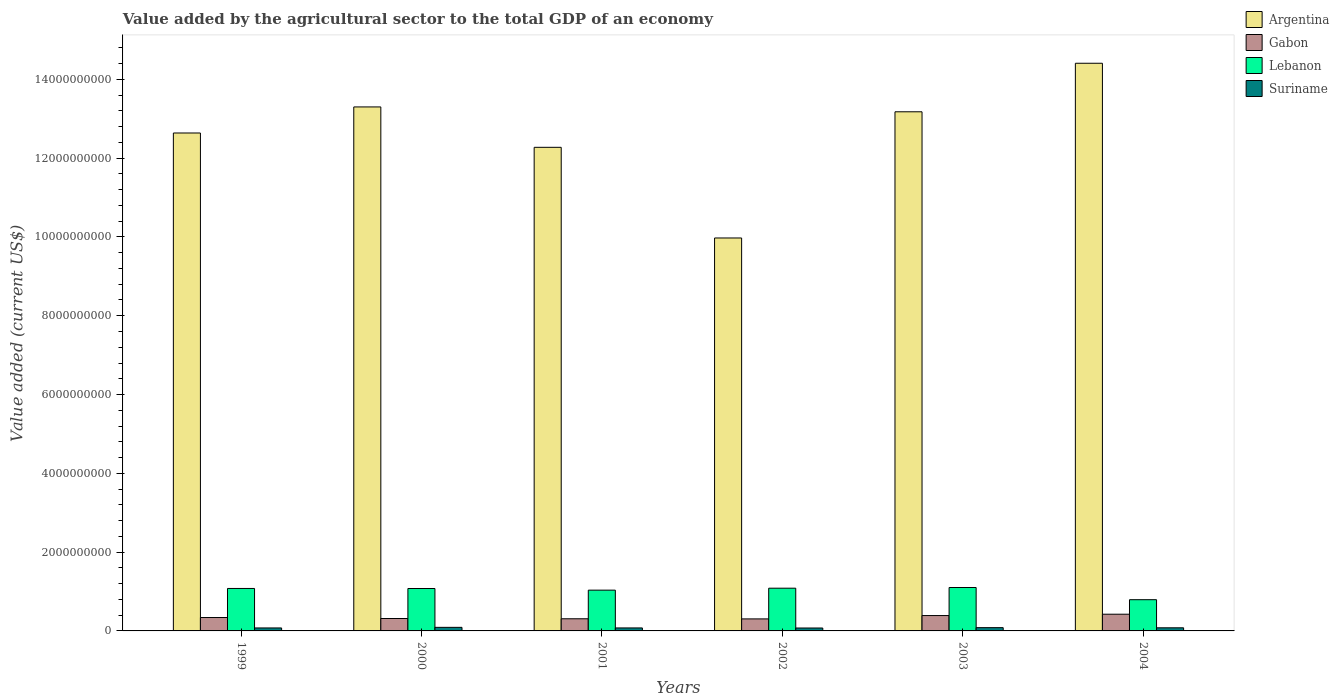How many different coloured bars are there?
Keep it short and to the point. 4. How many groups of bars are there?
Your answer should be very brief. 6. Are the number of bars on each tick of the X-axis equal?
Provide a succinct answer. Yes. What is the label of the 3rd group of bars from the left?
Keep it short and to the point. 2001. In how many cases, is the number of bars for a given year not equal to the number of legend labels?
Provide a succinct answer. 0. What is the value added by the agricultural sector to the total GDP in Argentina in 1999?
Offer a very short reply. 1.26e+1. Across all years, what is the maximum value added by the agricultural sector to the total GDP in Gabon?
Make the answer very short. 4.24e+08. Across all years, what is the minimum value added by the agricultural sector to the total GDP in Argentina?
Your response must be concise. 9.97e+09. In which year was the value added by the agricultural sector to the total GDP in Suriname maximum?
Your response must be concise. 2000. What is the total value added by the agricultural sector to the total GDP in Suriname in the graph?
Make the answer very short. 4.78e+08. What is the difference between the value added by the agricultural sector to the total GDP in Lebanon in 2002 and that in 2004?
Provide a succinct answer. 2.92e+08. What is the difference between the value added by the agricultural sector to the total GDP in Argentina in 2003 and the value added by the agricultural sector to the total GDP in Suriname in 2004?
Your response must be concise. 1.31e+1. What is the average value added by the agricultural sector to the total GDP in Suriname per year?
Your answer should be very brief. 7.97e+07. In the year 2002, what is the difference between the value added by the agricultural sector to the total GDP in Gabon and value added by the agricultural sector to the total GDP in Lebanon?
Provide a short and direct response. -7.80e+08. What is the ratio of the value added by the agricultural sector to the total GDP in Lebanon in 1999 to that in 2001?
Ensure brevity in your answer.  1.04. What is the difference between the highest and the second highest value added by the agricultural sector to the total GDP in Gabon?
Your answer should be compact. 3.40e+07. What is the difference between the highest and the lowest value added by the agricultural sector to the total GDP in Lebanon?
Provide a succinct answer. 3.09e+08. Is the sum of the value added by the agricultural sector to the total GDP in Lebanon in 2001 and 2002 greater than the maximum value added by the agricultural sector to the total GDP in Argentina across all years?
Provide a succinct answer. No. Is it the case that in every year, the sum of the value added by the agricultural sector to the total GDP in Argentina and value added by the agricultural sector to the total GDP in Lebanon is greater than the sum of value added by the agricultural sector to the total GDP in Suriname and value added by the agricultural sector to the total GDP in Gabon?
Offer a very short reply. Yes. What does the 2nd bar from the left in 2004 represents?
Give a very brief answer. Gabon. What does the 4th bar from the right in 2000 represents?
Provide a short and direct response. Argentina. Are all the bars in the graph horizontal?
Make the answer very short. No. Does the graph contain grids?
Keep it short and to the point. No. Where does the legend appear in the graph?
Offer a terse response. Top right. What is the title of the graph?
Ensure brevity in your answer.  Value added by the agricultural sector to the total GDP of an economy. Does "Cabo Verde" appear as one of the legend labels in the graph?
Ensure brevity in your answer.  No. What is the label or title of the Y-axis?
Offer a terse response. Value added (current US$). What is the Value added (current US$) in Argentina in 1999?
Keep it short and to the point. 1.26e+1. What is the Value added (current US$) of Gabon in 1999?
Your answer should be compact. 3.40e+08. What is the Value added (current US$) in Lebanon in 1999?
Your answer should be very brief. 1.08e+09. What is the Value added (current US$) in Suriname in 1999?
Ensure brevity in your answer.  7.56e+07. What is the Value added (current US$) in Argentina in 2000?
Offer a terse response. 1.33e+1. What is the Value added (current US$) of Gabon in 2000?
Keep it short and to the point. 3.15e+08. What is the Value added (current US$) of Lebanon in 2000?
Keep it short and to the point. 1.08e+09. What is the Value added (current US$) of Suriname in 2000?
Your answer should be compact. 9.07e+07. What is the Value added (current US$) of Argentina in 2001?
Ensure brevity in your answer.  1.23e+1. What is the Value added (current US$) in Gabon in 2001?
Make the answer very short. 3.08e+08. What is the Value added (current US$) in Lebanon in 2001?
Make the answer very short. 1.03e+09. What is the Value added (current US$) in Suriname in 2001?
Make the answer very short. 7.59e+07. What is the Value added (current US$) in Argentina in 2002?
Make the answer very short. 9.97e+09. What is the Value added (current US$) in Gabon in 2002?
Provide a succinct answer. 3.05e+08. What is the Value added (current US$) of Lebanon in 2002?
Provide a succinct answer. 1.08e+09. What is the Value added (current US$) of Suriname in 2002?
Ensure brevity in your answer.  7.38e+07. What is the Value added (current US$) of Argentina in 2003?
Keep it short and to the point. 1.32e+1. What is the Value added (current US$) in Gabon in 2003?
Ensure brevity in your answer.  3.90e+08. What is the Value added (current US$) of Lebanon in 2003?
Make the answer very short. 1.10e+09. What is the Value added (current US$) of Suriname in 2003?
Ensure brevity in your answer.  8.31e+07. What is the Value added (current US$) in Argentina in 2004?
Your answer should be very brief. 1.44e+1. What is the Value added (current US$) of Gabon in 2004?
Your answer should be very brief. 4.24e+08. What is the Value added (current US$) in Lebanon in 2004?
Your response must be concise. 7.93e+08. What is the Value added (current US$) in Suriname in 2004?
Keep it short and to the point. 7.91e+07. Across all years, what is the maximum Value added (current US$) in Argentina?
Make the answer very short. 1.44e+1. Across all years, what is the maximum Value added (current US$) of Gabon?
Give a very brief answer. 4.24e+08. Across all years, what is the maximum Value added (current US$) in Lebanon?
Provide a short and direct response. 1.10e+09. Across all years, what is the maximum Value added (current US$) of Suriname?
Ensure brevity in your answer.  9.07e+07. Across all years, what is the minimum Value added (current US$) of Argentina?
Provide a short and direct response. 9.97e+09. Across all years, what is the minimum Value added (current US$) of Gabon?
Offer a terse response. 3.05e+08. Across all years, what is the minimum Value added (current US$) of Lebanon?
Provide a short and direct response. 7.93e+08. Across all years, what is the minimum Value added (current US$) in Suriname?
Your answer should be very brief. 7.38e+07. What is the total Value added (current US$) in Argentina in the graph?
Ensure brevity in your answer.  7.58e+1. What is the total Value added (current US$) of Gabon in the graph?
Make the answer very short. 2.08e+09. What is the total Value added (current US$) in Lebanon in the graph?
Your answer should be compact. 6.17e+09. What is the total Value added (current US$) in Suriname in the graph?
Provide a succinct answer. 4.78e+08. What is the difference between the Value added (current US$) in Argentina in 1999 and that in 2000?
Your response must be concise. -6.62e+08. What is the difference between the Value added (current US$) in Gabon in 1999 and that in 2000?
Your response must be concise. 2.52e+07. What is the difference between the Value added (current US$) in Lebanon in 1999 and that in 2000?
Offer a terse response. 1.08e+06. What is the difference between the Value added (current US$) in Suriname in 1999 and that in 2000?
Provide a succinct answer. -1.51e+07. What is the difference between the Value added (current US$) in Argentina in 1999 and that in 2001?
Your answer should be very brief. 3.64e+08. What is the difference between the Value added (current US$) of Gabon in 1999 and that in 2001?
Make the answer very short. 3.17e+07. What is the difference between the Value added (current US$) in Lebanon in 1999 and that in 2001?
Make the answer very short. 4.29e+07. What is the difference between the Value added (current US$) in Suriname in 1999 and that in 2001?
Your answer should be compact. -2.60e+05. What is the difference between the Value added (current US$) in Argentina in 1999 and that in 2002?
Make the answer very short. 2.66e+09. What is the difference between the Value added (current US$) in Gabon in 1999 and that in 2002?
Provide a succinct answer. 3.51e+07. What is the difference between the Value added (current US$) in Lebanon in 1999 and that in 2002?
Keep it short and to the point. -6.88e+06. What is the difference between the Value added (current US$) in Suriname in 1999 and that in 2002?
Ensure brevity in your answer.  1.75e+06. What is the difference between the Value added (current US$) in Argentina in 1999 and that in 2003?
Provide a short and direct response. -5.38e+08. What is the difference between the Value added (current US$) in Gabon in 1999 and that in 2003?
Your answer should be compact. -5.00e+07. What is the difference between the Value added (current US$) of Lebanon in 1999 and that in 2003?
Make the answer very short. -2.41e+07. What is the difference between the Value added (current US$) in Suriname in 1999 and that in 2003?
Your response must be concise. -7.55e+06. What is the difference between the Value added (current US$) in Argentina in 1999 and that in 2004?
Offer a very short reply. -1.77e+09. What is the difference between the Value added (current US$) in Gabon in 1999 and that in 2004?
Your answer should be very brief. -8.40e+07. What is the difference between the Value added (current US$) of Lebanon in 1999 and that in 2004?
Give a very brief answer. 2.85e+08. What is the difference between the Value added (current US$) of Suriname in 1999 and that in 2004?
Your response must be concise. -3.50e+06. What is the difference between the Value added (current US$) in Argentina in 2000 and that in 2001?
Make the answer very short. 1.02e+09. What is the difference between the Value added (current US$) in Gabon in 2000 and that in 2001?
Keep it short and to the point. 6.54e+06. What is the difference between the Value added (current US$) of Lebanon in 2000 and that in 2001?
Ensure brevity in your answer.  4.18e+07. What is the difference between the Value added (current US$) in Suriname in 2000 and that in 2001?
Offer a very short reply. 1.48e+07. What is the difference between the Value added (current US$) of Argentina in 2000 and that in 2002?
Offer a very short reply. 3.33e+09. What is the difference between the Value added (current US$) in Gabon in 2000 and that in 2002?
Make the answer very short. 9.88e+06. What is the difference between the Value added (current US$) in Lebanon in 2000 and that in 2002?
Ensure brevity in your answer.  -7.96e+06. What is the difference between the Value added (current US$) of Suriname in 2000 and that in 2002?
Provide a succinct answer. 1.68e+07. What is the difference between the Value added (current US$) in Argentina in 2000 and that in 2003?
Provide a succinct answer. 1.23e+08. What is the difference between the Value added (current US$) in Gabon in 2000 and that in 2003?
Your answer should be very brief. -7.52e+07. What is the difference between the Value added (current US$) of Lebanon in 2000 and that in 2003?
Provide a short and direct response. -2.52e+07. What is the difference between the Value added (current US$) of Suriname in 2000 and that in 2003?
Give a very brief answer. 7.52e+06. What is the difference between the Value added (current US$) in Argentina in 2000 and that in 2004?
Your answer should be very brief. -1.11e+09. What is the difference between the Value added (current US$) in Gabon in 2000 and that in 2004?
Give a very brief answer. -1.09e+08. What is the difference between the Value added (current US$) of Lebanon in 2000 and that in 2004?
Provide a succinct answer. 2.84e+08. What is the difference between the Value added (current US$) in Suriname in 2000 and that in 2004?
Your answer should be compact. 1.16e+07. What is the difference between the Value added (current US$) in Argentina in 2001 and that in 2002?
Offer a very short reply. 2.30e+09. What is the difference between the Value added (current US$) in Gabon in 2001 and that in 2002?
Offer a terse response. 3.34e+06. What is the difference between the Value added (current US$) of Lebanon in 2001 and that in 2002?
Offer a very short reply. -4.98e+07. What is the difference between the Value added (current US$) of Suriname in 2001 and that in 2002?
Ensure brevity in your answer.  2.01e+06. What is the difference between the Value added (current US$) in Argentina in 2001 and that in 2003?
Give a very brief answer. -9.02e+08. What is the difference between the Value added (current US$) in Gabon in 2001 and that in 2003?
Your response must be concise. -8.17e+07. What is the difference between the Value added (current US$) of Lebanon in 2001 and that in 2003?
Ensure brevity in your answer.  -6.70e+07. What is the difference between the Value added (current US$) in Suriname in 2001 and that in 2003?
Your response must be concise. -7.29e+06. What is the difference between the Value added (current US$) in Argentina in 2001 and that in 2004?
Give a very brief answer. -2.13e+09. What is the difference between the Value added (current US$) of Gabon in 2001 and that in 2004?
Provide a short and direct response. -1.16e+08. What is the difference between the Value added (current US$) of Lebanon in 2001 and that in 2004?
Offer a very short reply. 2.42e+08. What is the difference between the Value added (current US$) of Suriname in 2001 and that in 2004?
Give a very brief answer. -3.24e+06. What is the difference between the Value added (current US$) in Argentina in 2002 and that in 2003?
Provide a succinct answer. -3.20e+09. What is the difference between the Value added (current US$) in Gabon in 2002 and that in 2003?
Offer a terse response. -8.51e+07. What is the difference between the Value added (current US$) in Lebanon in 2002 and that in 2003?
Offer a terse response. -1.72e+07. What is the difference between the Value added (current US$) of Suriname in 2002 and that in 2003?
Make the answer very short. -9.30e+06. What is the difference between the Value added (current US$) in Argentina in 2002 and that in 2004?
Provide a succinct answer. -4.43e+09. What is the difference between the Value added (current US$) in Gabon in 2002 and that in 2004?
Your response must be concise. -1.19e+08. What is the difference between the Value added (current US$) of Lebanon in 2002 and that in 2004?
Provide a short and direct response. 2.92e+08. What is the difference between the Value added (current US$) of Suriname in 2002 and that in 2004?
Offer a very short reply. -5.26e+06. What is the difference between the Value added (current US$) of Argentina in 2003 and that in 2004?
Your response must be concise. -1.23e+09. What is the difference between the Value added (current US$) in Gabon in 2003 and that in 2004?
Your response must be concise. -3.40e+07. What is the difference between the Value added (current US$) of Lebanon in 2003 and that in 2004?
Give a very brief answer. 3.09e+08. What is the difference between the Value added (current US$) of Suriname in 2003 and that in 2004?
Make the answer very short. 4.04e+06. What is the difference between the Value added (current US$) in Argentina in 1999 and the Value added (current US$) in Gabon in 2000?
Offer a very short reply. 1.23e+1. What is the difference between the Value added (current US$) in Argentina in 1999 and the Value added (current US$) in Lebanon in 2000?
Keep it short and to the point. 1.16e+1. What is the difference between the Value added (current US$) in Argentina in 1999 and the Value added (current US$) in Suriname in 2000?
Keep it short and to the point. 1.25e+1. What is the difference between the Value added (current US$) of Gabon in 1999 and the Value added (current US$) of Lebanon in 2000?
Provide a succinct answer. -7.37e+08. What is the difference between the Value added (current US$) in Gabon in 1999 and the Value added (current US$) in Suriname in 2000?
Make the answer very short. 2.49e+08. What is the difference between the Value added (current US$) of Lebanon in 1999 and the Value added (current US$) of Suriname in 2000?
Keep it short and to the point. 9.87e+08. What is the difference between the Value added (current US$) in Argentina in 1999 and the Value added (current US$) in Gabon in 2001?
Provide a short and direct response. 1.23e+1. What is the difference between the Value added (current US$) in Argentina in 1999 and the Value added (current US$) in Lebanon in 2001?
Provide a short and direct response. 1.16e+1. What is the difference between the Value added (current US$) of Argentina in 1999 and the Value added (current US$) of Suriname in 2001?
Give a very brief answer. 1.26e+1. What is the difference between the Value added (current US$) of Gabon in 1999 and the Value added (current US$) of Lebanon in 2001?
Offer a very short reply. -6.95e+08. What is the difference between the Value added (current US$) in Gabon in 1999 and the Value added (current US$) in Suriname in 2001?
Provide a short and direct response. 2.64e+08. What is the difference between the Value added (current US$) of Lebanon in 1999 and the Value added (current US$) of Suriname in 2001?
Offer a terse response. 1.00e+09. What is the difference between the Value added (current US$) of Argentina in 1999 and the Value added (current US$) of Gabon in 2002?
Provide a short and direct response. 1.23e+1. What is the difference between the Value added (current US$) in Argentina in 1999 and the Value added (current US$) in Lebanon in 2002?
Your response must be concise. 1.16e+1. What is the difference between the Value added (current US$) of Argentina in 1999 and the Value added (current US$) of Suriname in 2002?
Make the answer very short. 1.26e+1. What is the difference between the Value added (current US$) of Gabon in 1999 and the Value added (current US$) of Lebanon in 2002?
Your response must be concise. -7.44e+08. What is the difference between the Value added (current US$) in Gabon in 1999 and the Value added (current US$) in Suriname in 2002?
Give a very brief answer. 2.66e+08. What is the difference between the Value added (current US$) in Lebanon in 1999 and the Value added (current US$) in Suriname in 2002?
Your answer should be compact. 1.00e+09. What is the difference between the Value added (current US$) of Argentina in 1999 and the Value added (current US$) of Gabon in 2003?
Keep it short and to the point. 1.22e+1. What is the difference between the Value added (current US$) in Argentina in 1999 and the Value added (current US$) in Lebanon in 2003?
Provide a succinct answer. 1.15e+1. What is the difference between the Value added (current US$) of Argentina in 1999 and the Value added (current US$) of Suriname in 2003?
Your response must be concise. 1.26e+1. What is the difference between the Value added (current US$) of Gabon in 1999 and the Value added (current US$) of Lebanon in 2003?
Your answer should be compact. -7.62e+08. What is the difference between the Value added (current US$) in Gabon in 1999 and the Value added (current US$) in Suriname in 2003?
Provide a succinct answer. 2.57e+08. What is the difference between the Value added (current US$) in Lebanon in 1999 and the Value added (current US$) in Suriname in 2003?
Keep it short and to the point. 9.95e+08. What is the difference between the Value added (current US$) in Argentina in 1999 and the Value added (current US$) in Gabon in 2004?
Ensure brevity in your answer.  1.22e+1. What is the difference between the Value added (current US$) in Argentina in 1999 and the Value added (current US$) in Lebanon in 2004?
Offer a very short reply. 1.18e+1. What is the difference between the Value added (current US$) of Argentina in 1999 and the Value added (current US$) of Suriname in 2004?
Give a very brief answer. 1.26e+1. What is the difference between the Value added (current US$) of Gabon in 1999 and the Value added (current US$) of Lebanon in 2004?
Ensure brevity in your answer.  -4.53e+08. What is the difference between the Value added (current US$) in Gabon in 1999 and the Value added (current US$) in Suriname in 2004?
Keep it short and to the point. 2.61e+08. What is the difference between the Value added (current US$) in Lebanon in 1999 and the Value added (current US$) in Suriname in 2004?
Ensure brevity in your answer.  9.99e+08. What is the difference between the Value added (current US$) of Argentina in 2000 and the Value added (current US$) of Gabon in 2001?
Give a very brief answer. 1.30e+1. What is the difference between the Value added (current US$) of Argentina in 2000 and the Value added (current US$) of Lebanon in 2001?
Keep it short and to the point. 1.23e+1. What is the difference between the Value added (current US$) of Argentina in 2000 and the Value added (current US$) of Suriname in 2001?
Your answer should be compact. 1.32e+1. What is the difference between the Value added (current US$) in Gabon in 2000 and the Value added (current US$) in Lebanon in 2001?
Offer a terse response. -7.20e+08. What is the difference between the Value added (current US$) of Gabon in 2000 and the Value added (current US$) of Suriname in 2001?
Provide a succinct answer. 2.39e+08. What is the difference between the Value added (current US$) of Lebanon in 2000 and the Value added (current US$) of Suriname in 2001?
Your response must be concise. 1.00e+09. What is the difference between the Value added (current US$) of Argentina in 2000 and the Value added (current US$) of Gabon in 2002?
Provide a succinct answer. 1.30e+1. What is the difference between the Value added (current US$) in Argentina in 2000 and the Value added (current US$) in Lebanon in 2002?
Offer a very short reply. 1.22e+1. What is the difference between the Value added (current US$) in Argentina in 2000 and the Value added (current US$) in Suriname in 2002?
Provide a short and direct response. 1.32e+1. What is the difference between the Value added (current US$) in Gabon in 2000 and the Value added (current US$) in Lebanon in 2002?
Offer a terse response. -7.70e+08. What is the difference between the Value added (current US$) in Gabon in 2000 and the Value added (current US$) in Suriname in 2002?
Provide a succinct answer. 2.41e+08. What is the difference between the Value added (current US$) of Lebanon in 2000 and the Value added (current US$) of Suriname in 2002?
Make the answer very short. 1.00e+09. What is the difference between the Value added (current US$) in Argentina in 2000 and the Value added (current US$) in Gabon in 2003?
Ensure brevity in your answer.  1.29e+1. What is the difference between the Value added (current US$) of Argentina in 2000 and the Value added (current US$) of Lebanon in 2003?
Keep it short and to the point. 1.22e+1. What is the difference between the Value added (current US$) in Argentina in 2000 and the Value added (current US$) in Suriname in 2003?
Offer a very short reply. 1.32e+1. What is the difference between the Value added (current US$) of Gabon in 2000 and the Value added (current US$) of Lebanon in 2003?
Offer a very short reply. -7.87e+08. What is the difference between the Value added (current US$) in Gabon in 2000 and the Value added (current US$) in Suriname in 2003?
Offer a very short reply. 2.32e+08. What is the difference between the Value added (current US$) of Lebanon in 2000 and the Value added (current US$) of Suriname in 2003?
Your response must be concise. 9.93e+08. What is the difference between the Value added (current US$) in Argentina in 2000 and the Value added (current US$) in Gabon in 2004?
Your answer should be very brief. 1.29e+1. What is the difference between the Value added (current US$) of Argentina in 2000 and the Value added (current US$) of Lebanon in 2004?
Offer a very short reply. 1.25e+1. What is the difference between the Value added (current US$) of Argentina in 2000 and the Value added (current US$) of Suriname in 2004?
Offer a terse response. 1.32e+1. What is the difference between the Value added (current US$) in Gabon in 2000 and the Value added (current US$) in Lebanon in 2004?
Provide a succinct answer. -4.78e+08. What is the difference between the Value added (current US$) in Gabon in 2000 and the Value added (current US$) in Suriname in 2004?
Your answer should be very brief. 2.36e+08. What is the difference between the Value added (current US$) in Lebanon in 2000 and the Value added (current US$) in Suriname in 2004?
Ensure brevity in your answer.  9.98e+08. What is the difference between the Value added (current US$) in Argentina in 2001 and the Value added (current US$) in Gabon in 2002?
Your answer should be compact. 1.20e+1. What is the difference between the Value added (current US$) of Argentina in 2001 and the Value added (current US$) of Lebanon in 2002?
Your answer should be very brief. 1.12e+1. What is the difference between the Value added (current US$) in Argentina in 2001 and the Value added (current US$) in Suriname in 2002?
Your response must be concise. 1.22e+1. What is the difference between the Value added (current US$) in Gabon in 2001 and the Value added (current US$) in Lebanon in 2002?
Provide a succinct answer. -7.76e+08. What is the difference between the Value added (current US$) of Gabon in 2001 and the Value added (current US$) of Suriname in 2002?
Your answer should be very brief. 2.35e+08. What is the difference between the Value added (current US$) of Lebanon in 2001 and the Value added (current US$) of Suriname in 2002?
Ensure brevity in your answer.  9.61e+08. What is the difference between the Value added (current US$) of Argentina in 2001 and the Value added (current US$) of Gabon in 2003?
Ensure brevity in your answer.  1.19e+1. What is the difference between the Value added (current US$) of Argentina in 2001 and the Value added (current US$) of Lebanon in 2003?
Your answer should be compact. 1.12e+1. What is the difference between the Value added (current US$) of Argentina in 2001 and the Value added (current US$) of Suriname in 2003?
Provide a short and direct response. 1.22e+1. What is the difference between the Value added (current US$) of Gabon in 2001 and the Value added (current US$) of Lebanon in 2003?
Ensure brevity in your answer.  -7.93e+08. What is the difference between the Value added (current US$) in Gabon in 2001 and the Value added (current US$) in Suriname in 2003?
Ensure brevity in your answer.  2.25e+08. What is the difference between the Value added (current US$) of Lebanon in 2001 and the Value added (current US$) of Suriname in 2003?
Your answer should be very brief. 9.52e+08. What is the difference between the Value added (current US$) of Argentina in 2001 and the Value added (current US$) of Gabon in 2004?
Your response must be concise. 1.19e+1. What is the difference between the Value added (current US$) in Argentina in 2001 and the Value added (current US$) in Lebanon in 2004?
Provide a short and direct response. 1.15e+1. What is the difference between the Value added (current US$) in Argentina in 2001 and the Value added (current US$) in Suriname in 2004?
Offer a terse response. 1.22e+1. What is the difference between the Value added (current US$) of Gabon in 2001 and the Value added (current US$) of Lebanon in 2004?
Ensure brevity in your answer.  -4.84e+08. What is the difference between the Value added (current US$) of Gabon in 2001 and the Value added (current US$) of Suriname in 2004?
Your answer should be compact. 2.29e+08. What is the difference between the Value added (current US$) of Lebanon in 2001 and the Value added (current US$) of Suriname in 2004?
Ensure brevity in your answer.  9.56e+08. What is the difference between the Value added (current US$) of Argentina in 2002 and the Value added (current US$) of Gabon in 2003?
Your answer should be very brief. 9.58e+09. What is the difference between the Value added (current US$) in Argentina in 2002 and the Value added (current US$) in Lebanon in 2003?
Provide a short and direct response. 8.87e+09. What is the difference between the Value added (current US$) of Argentina in 2002 and the Value added (current US$) of Suriname in 2003?
Your answer should be compact. 9.89e+09. What is the difference between the Value added (current US$) of Gabon in 2002 and the Value added (current US$) of Lebanon in 2003?
Give a very brief answer. -7.97e+08. What is the difference between the Value added (current US$) of Gabon in 2002 and the Value added (current US$) of Suriname in 2003?
Your response must be concise. 2.22e+08. What is the difference between the Value added (current US$) in Lebanon in 2002 and the Value added (current US$) in Suriname in 2003?
Your answer should be compact. 1.00e+09. What is the difference between the Value added (current US$) of Argentina in 2002 and the Value added (current US$) of Gabon in 2004?
Keep it short and to the point. 9.55e+09. What is the difference between the Value added (current US$) in Argentina in 2002 and the Value added (current US$) in Lebanon in 2004?
Provide a succinct answer. 9.18e+09. What is the difference between the Value added (current US$) in Argentina in 2002 and the Value added (current US$) in Suriname in 2004?
Offer a terse response. 9.90e+09. What is the difference between the Value added (current US$) in Gabon in 2002 and the Value added (current US$) in Lebanon in 2004?
Offer a very short reply. -4.88e+08. What is the difference between the Value added (current US$) in Gabon in 2002 and the Value added (current US$) in Suriname in 2004?
Provide a short and direct response. 2.26e+08. What is the difference between the Value added (current US$) of Lebanon in 2002 and the Value added (current US$) of Suriname in 2004?
Your answer should be compact. 1.01e+09. What is the difference between the Value added (current US$) of Argentina in 2003 and the Value added (current US$) of Gabon in 2004?
Offer a very short reply. 1.28e+1. What is the difference between the Value added (current US$) of Argentina in 2003 and the Value added (current US$) of Lebanon in 2004?
Give a very brief answer. 1.24e+1. What is the difference between the Value added (current US$) of Argentina in 2003 and the Value added (current US$) of Suriname in 2004?
Provide a succinct answer. 1.31e+1. What is the difference between the Value added (current US$) in Gabon in 2003 and the Value added (current US$) in Lebanon in 2004?
Keep it short and to the point. -4.03e+08. What is the difference between the Value added (current US$) of Gabon in 2003 and the Value added (current US$) of Suriname in 2004?
Provide a succinct answer. 3.11e+08. What is the difference between the Value added (current US$) in Lebanon in 2003 and the Value added (current US$) in Suriname in 2004?
Ensure brevity in your answer.  1.02e+09. What is the average Value added (current US$) in Argentina per year?
Provide a succinct answer. 1.26e+1. What is the average Value added (current US$) in Gabon per year?
Your answer should be compact. 3.47e+08. What is the average Value added (current US$) of Lebanon per year?
Provide a succinct answer. 1.03e+09. What is the average Value added (current US$) in Suriname per year?
Keep it short and to the point. 7.97e+07. In the year 1999, what is the difference between the Value added (current US$) in Argentina and Value added (current US$) in Gabon?
Ensure brevity in your answer.  1.23e+1. In the year 1999, what is the difference between the Value added (current US$) of Argentina and Value added (current US$) of Lebanon?
Your response must be concise. 1.16e+1. In the year 1999, what is the difference between the Value added (current US$) in Argentina and Value added (current US$) in Suriname?
Offer a terse response. 1.26e+1. In the year 1999, what is the difference between the Value added (current US$) of Gabon and Value added (current US$) of Lebanon?
Provide a succinct answer. -7.38e+08. In the year 1999, what is the difference between the Value added (current US$) of Gabon and Value added (current US$) of Suriname?
Provide a succinct answer. 2.65e+08. In the year 1999, what is the difference between the Value added (current US$) in Lebanon and Value added (current US$) in Suriname?
Give a very brief answer. 1.00e+09. In the year 2000, what is the difference between the Value added (current US$) of Argentina and Value added (current US$) of Gabon?
Offer a terse response. 1.30e+1. In the year 2000, what is the difference between the Value added (current US$) in Argentina and Value added (current US$) in Lebanon?
Your response must be concise. 1.22e+1. In the year 2000, what is the difference between the Value added (current US$) in Argentina and Value added (current US$) in Suriname?
Offer a very short reply. 1.32e+1. In the year 2000, what is the difference between the Value added (current US$) in Gabon and Value added (current US$) in Lebanon?
Offer a very short reply. -7.62e+08. In the year 2000, what is the difference between the Value added (current US$) in Gabon and Value added (current US$) in Suriname?
Offer a very short reply. 2.24e+08. In the year 2000, what is the difference between the Value added (current US$) of Lebanon and Value added (current US$) of Suriname?
Ensure brevity in your answer.  9.86e+08. In the year 2001, what is the difference between the Value added (current US$) in Argentina and Value added (current US$) in Gabon?
Offer a terse response. 1.20e+1. In the year 2001, what is the difference between the Value added (current US$) in Argentina and Value added (current US$) in Lebanon?
Give a very brief answer. 1.12e+1. In the year 2001, what is the difference between the Value added (current US$) in Argentina and Value added (current US$) in Suriname?
Keep it short and to the point. 1.22e+1. In the year 2001, what is the difference between the Value added (current US$) of Gabon and Value added (current US$) of Lebanon?
Your answer should be compact. -7.26e+08. In the year 2001, what is the difference between the Value added (current US$) of Gabon and Value added (current US$) of Suriname?
Ensure brevity in your answer.  2.33e+08. In the year 2001, what is the difference between the Value added (current US$) of Lebanon and Value added (current US$) of Suriname?
Make the answer very short. 9.59e+08. In the year 2002, what is the difference between the Value added (current US$) in Argentina and Value added (current US$) in Gabon?
Offer a very short reply. 9.67e+09. In the year 2002, what is the difference between the Value added (current US$) of Argentina and Value added (current US$) of Lebanon?
Your answer should be compact. 8.89e+09. In the year 2002, what is the difference between the Value added (current US$) in Argentina and Value added (current US$) in Suriname?
Keep it short and to the point. 9.90e+09. In the year 2002, what is the difference between the Value added (current US$) in Gabon and Value added (current US$) in Lebanon?
Provide a succinct answer. -7.80e+08. In the year 2002, what is the difference between the Value added (current US$) of Gabon and Value added (current US$) of Suriname?
Offer a very short reply. 2.31e+08. In the year 2002, what is the difference between the Value added (current US$) in Lebanon and Value added (current US$) in Suriname?
Your answer should be compact. 1.01e+09. In the year 2003, what is the difference between the Value added (current US$) in Argentina and Value added (current US$) in Gabon?
Keep it short and to the point. 1.28e+1. In the year 2003, what is the difference between the Value added (current US$) in Argentina and Value added (current US$) in Lebanon?
Ensure brevity in your answer.  1.21e+1. In the year 2003, what is the difference between the Value added (current US$) in Argentina and Value added (current US$) in Suriname?
Provide a succinct answer. 1.31e+1. In the year 2003, what is the difference between the Value added (current US$) in Gabon and Value added (current US$) in Lebanon?
Offer a terse response. -7.12e+08. In the year 2003, what is the difference between the Value added (current US$) in Gabon and Value added (current US$) in Suriname?
Provide a short and direct response. 3.07e+08. In the year 2003, what is the difference between the Value added (current US$) of Lebanon and Value added (current US$) of Suriname?
Provide a succinct answer. 1.02e+09. In the year 2004, what is the difference between the Value added (current US$) in Argentina and Value added (current US$) in Gabon?
Your answer should be compact. 1.40e+1. In the year 2004, what is the difference between the Value added (current US$) of Argentina and Value added (current US$) of Lebanon?
Keep it short and to the point. 1.36e+1. In the year 2004, what is the difference between the Value added (current US$) of Argentina and Value added (current US$) of Suriname?
Offer a terse response. 1.43e+1. In the year 2004, what is the difference between the Value added (current US$) in Gabon and Value added (current US$) in Lebanon?
Your answer should be very brief. -3.69e+08. In the year 2004, what is the difference between the Value added (current US$) in Gabon and Value added (current US$) in Suriname?
Offer a very short reply. 3.45e+08. In the year 2004, what is the difference between the Value added (current US$) of Lebanon and Value added (current US$) of Suriname?
Your answer should be compact. 7.14e+08. What is the ratio of the Value added (current US$) of Argentina in 1999 to that in 2000?
Offer a terse response. 0.95. What is the ratio of the Value added (current US$) in Gabon in 1999 to that in 2000?
Your response must be concise. 1.08. What is the ratio of the Value added (current US$) in Suriname in 1999 to that in 2000?
Your answer should be very brief. 0.83. What is the ratio of the Value added (current US$) in Argentina in 1999 to that in 2001?
Make the answer very short. 1.03. What is the ratio of the Value added (current US$) of Gabon in 1999 to that in 2001?
Offer a terse response. 1.1. What is the ratio of the Value added (current US$) of Lebanon in 1999 to that in 2001?
Make the answer very short. 1.04. What is the ratio of the Value added (current US$) in Argentina in 1999 to that in 2002?
Give a very brief answer. 1.27. What is the ratio of the Value added (current US$) in Gabon in 1999 to that in 2002?
Give a very brief answer. 1.11. What is the ratio of the Value added (current US$) of Lebanon in 1999 to that in 2002?
Provide a short and direct response. 0.99. What is the ratio of the Value added (current US$) of Suriname in 1999 to that in 2002?
Your answer should be compact. 1.02. What is the ratio of the Value added (current US$) in Argentina in 1999 to that in 2003?
Provide a short and direct response. 0.96. What is the ratio of the Value added (current US$) in Gabon in 1999 to that in 2003?
Give a very brief answer. 0.87. What is the ratio of the Value added (current US$) of Lebanon in 1999 to that in 2003?
Your response must be concise. 0.98. What is the ratio of the Value added (current US$) of Suriname in 1999 to that in 2003?
Offer a terse response. 0.91. What is the ratio of the Value added (current US$) of Argentina in 1999 to that in 2004?
Make the answer very short. 0.88. What is the ratio of the Value added (current US$) of Gabon in 1999 to that in 2004?
Give a very brief answer. 0.8. What is the ratio of the Value added (current US$) of Lebanon in 1999 to that in 2004?
Provide a short and direct response. 1.36. What is the ratio of the Value added (current US$) of Suriname in 1999 to that in 2004?
Ensure brevity in your answer.  0.96. What is the ratio of the Value added (current US$) in Argentina in 2000 to that in 2001?
Keep it short and to the point. 1.08. What is the ratio of the Value added (current US$) in Gabon in 2000 to that in 2001?
Ensure brevity in your answer.  1.02. What is the ratio of the Value added (current US$) of Lebanon in 2000 to that in 2001?
Offer a very short reply. 1.04. What is the ratio of the Value added (current US$) in Suriname in 2000 to that in 2001?
Provide a succinct answer. 1.2. What is the ratio of the Value added (current US$) of Argentina in 2000 to that in 2002?
Provide a succinct answer. 1.33. What is the ratio of the Value added (current US$) of Gabon in 2000 to that in 2002?
Offer a terse response. 1.03. What is the ratio of the Value added (current US$) in Suriname in 2000 to that in 2002?
Keep it short and to the point. 1.23. What is the ratio of the Value added (current US$) of Argentina in 2000 to that in 2003?
Keep it short and to the point. 1.01. What is the ratio of the Value added (current US$) of Gabon in 2000 to that in 2003?
Offer a very short reply. 0.81. What is the ratio of the Value added (current US$) of Lebanon in 2000 to that in 2003?
Your answer should be very brief. 0.98. What is the ratio of the Value added (current US$) of Suriname in 2000 to that in 2003?
Provide a short and direct response. 1.09. What is the ratio of the Value added (current US$) in Argentina in 2000 to that in 2004?
Give a very brief answer. 0.92. What is the ratio of the Value added (current US$) of Gabon in 2000 to that in 2004?
Your answer should be very brief. 0.74. What is the ratio of the Value added (current US$) of Lebanon in 2000 to that in 2004?
Provide a short and direct response. 1.36. What is the ratio of the Value added (current US$) in Suriname in 2000 to that in 2004?
Keep it short and to the point. 1.15. What is the ratio of the Value added (current US$) of Argentina in 2001 to that in 2002?
Ensure brevity in your answer.  1.23. What is the ratio of the Value added (current US$) of Gabon in 2001 to that in 2002?
Ensure brevity in your answer.  1.01. What is the ratio of the Value added (current US$) in Lebanon in 2001 to that in 2002?
Provide a succinct answer. 0.95. What is the ratio of the Value added (current US$) in Suriname in 2001 to that in 2002?
Make the answer very short. 1.03. What is the ratio of the Value added (current US$) of Argentina in 2001 to that in 2003?
Your response must be concise. 0.93. What is the ratio of the Value added (current US$) of Gabon in 2001 to that in 2003?
Make the answer very short. 0.79. What is the ratio of the Value added (current US$) in Lebanon in 2001 to that in 2003?
Give a very brief answer. 0.94. What is the ratio of the Value added (current US$) in Suriname in 2001 to that in 2003?
Make the answer very short. 0.91. What is the ratio of the Value added (current US$) in Argentina in 2001 to that in 2004?
Offer a terse response. 0.85. What is the ratio of the Value added (current US$) of Gabon in 2001 to that in 2004?
Offer a very short reply. 0.73. What is the ratio of the Value added (current US$) of Lebanon in 2001 to that in 2004?
Ensure brevity in your answer.  1.31. What is the ratio of the Value added (current US$) of Suriname in 2001 to that in 2004?
Your answer should be very brief. 0.96. What is the ratio of the Value added (current US$) of Argentina in 2002 to that in 2003?
Offer a very short reply. 0.76. What is the ratio of the Value added (current US$) of Gabon in 2002 to that in 2003?
Provide a succinct answer. 0.78. What is the ratio of the Value added (current US$) of Lebanon in 2002 to that in 2003?
Your answer should be very brief. 0.98. What is the ratio of the Value added (current US$) of Suriname in 2002 to that in 2003?
Your answer should be very brief. 0.89. What is the ratio of the Value added (current US$) of Argentina in 2002 to that in 2004?
Give a very brief answer. 0.69. What is the ratio of the Value added (current US$) of Gabon in 2002 to that in 2004?
Provide a succinct answer. 0.72. What is the ratio of the Value added (current US$) of Lebanon in 2002 to that in 2004?
Ensure brevity in your answer.  1.37. What is the ratio of the Value added (current US$) of Suriname in 2002 to that in 2004?
Offer a very short reply. 0.93. What is the ratio of the Value added (current US$) of Argentina in 2003 to that in 2004?
Your response must be concise. 0.91. What is the ratio of the Value added (current US$) in Gabon in 2003 to that in 2004?
Offer a very short reply. 0.92. What is the ratio of the Value added (current US$) of Lebanon in 2003 to that in 2004?
Give a very brief answer. 1.39. What is the ratio of the Value added (current US$) of Suriname in 2003 to that in 2004?
Provide a succinct answer. 1.05. What is the difference between the highest and the second highest Value added (current US$) in Argentina?
Provide a short and direct response. 1.11e+09. What is the difference between the highest and the second highest Value added (current US$) of Gabon?
Give a very brief answer. 3.40e+07. What is the difference between the highest and the second highest Value added (current US$) in Lebanon?
Offer a terse response. 1.72e+07. What is the difference between the highest and the second highest Value added (current US$) in Suriname?
Provide a succinct answer. 7.52e+06. What is the difference between the highest and the lowest Value added (current US$) in Argentina?
Provide a short and direct response. 4.43e+09. What is the difference between the highest and the lowest Value added (current US$) of Gabon?
Your response must be concise. 1.19e+08. What is the difference between the highest and the lowest Value added (current US$) in Lebanon?
Keep it short and to the point. 3.09e+08. What is the difference between the highest and the lowest Value added (current US$) in Suriname?
Keep it short and to the point. 1.68e+07. 